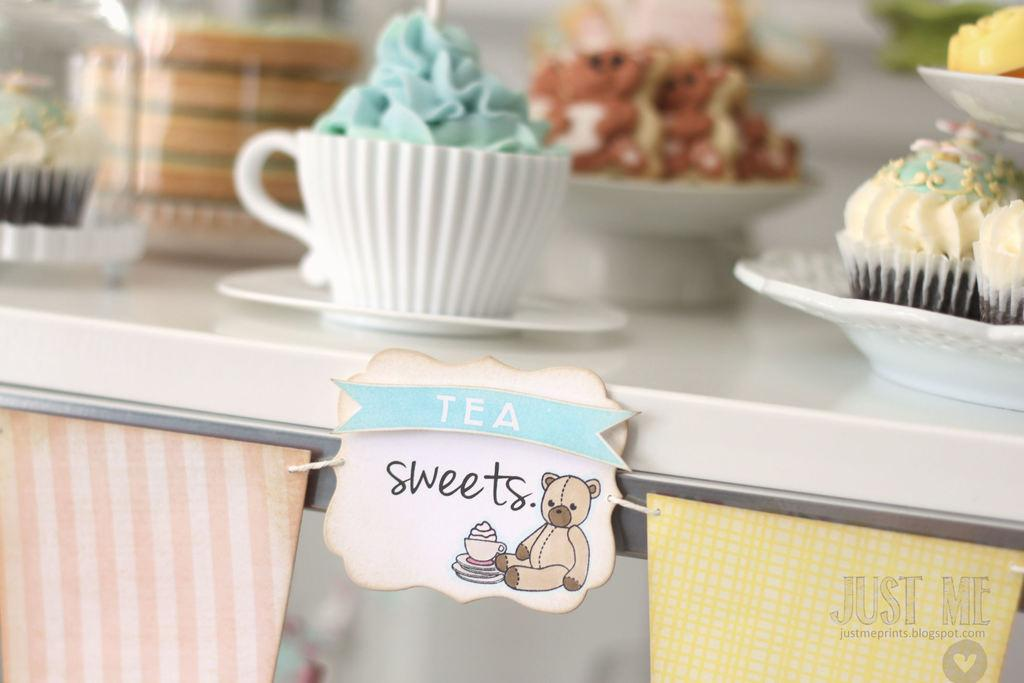What type of dessert is featured in the image? There are cupcakes in the image. What is on top of the cupcakes? The cupcakes have cream and sprinkles on them. Where are the cupcakes located? The cupcakes are placed on a table. What else can be seen on the table? There is a board in the image. What is on the board? There is a teddy bear and writing on the board. How many bikes are parked next to the table in the image? There are no bikes present in the image. What type of jar is used to store the cupcakes in the image? There is no jar used to store the cupcakes in the image; they are placed on a table. 